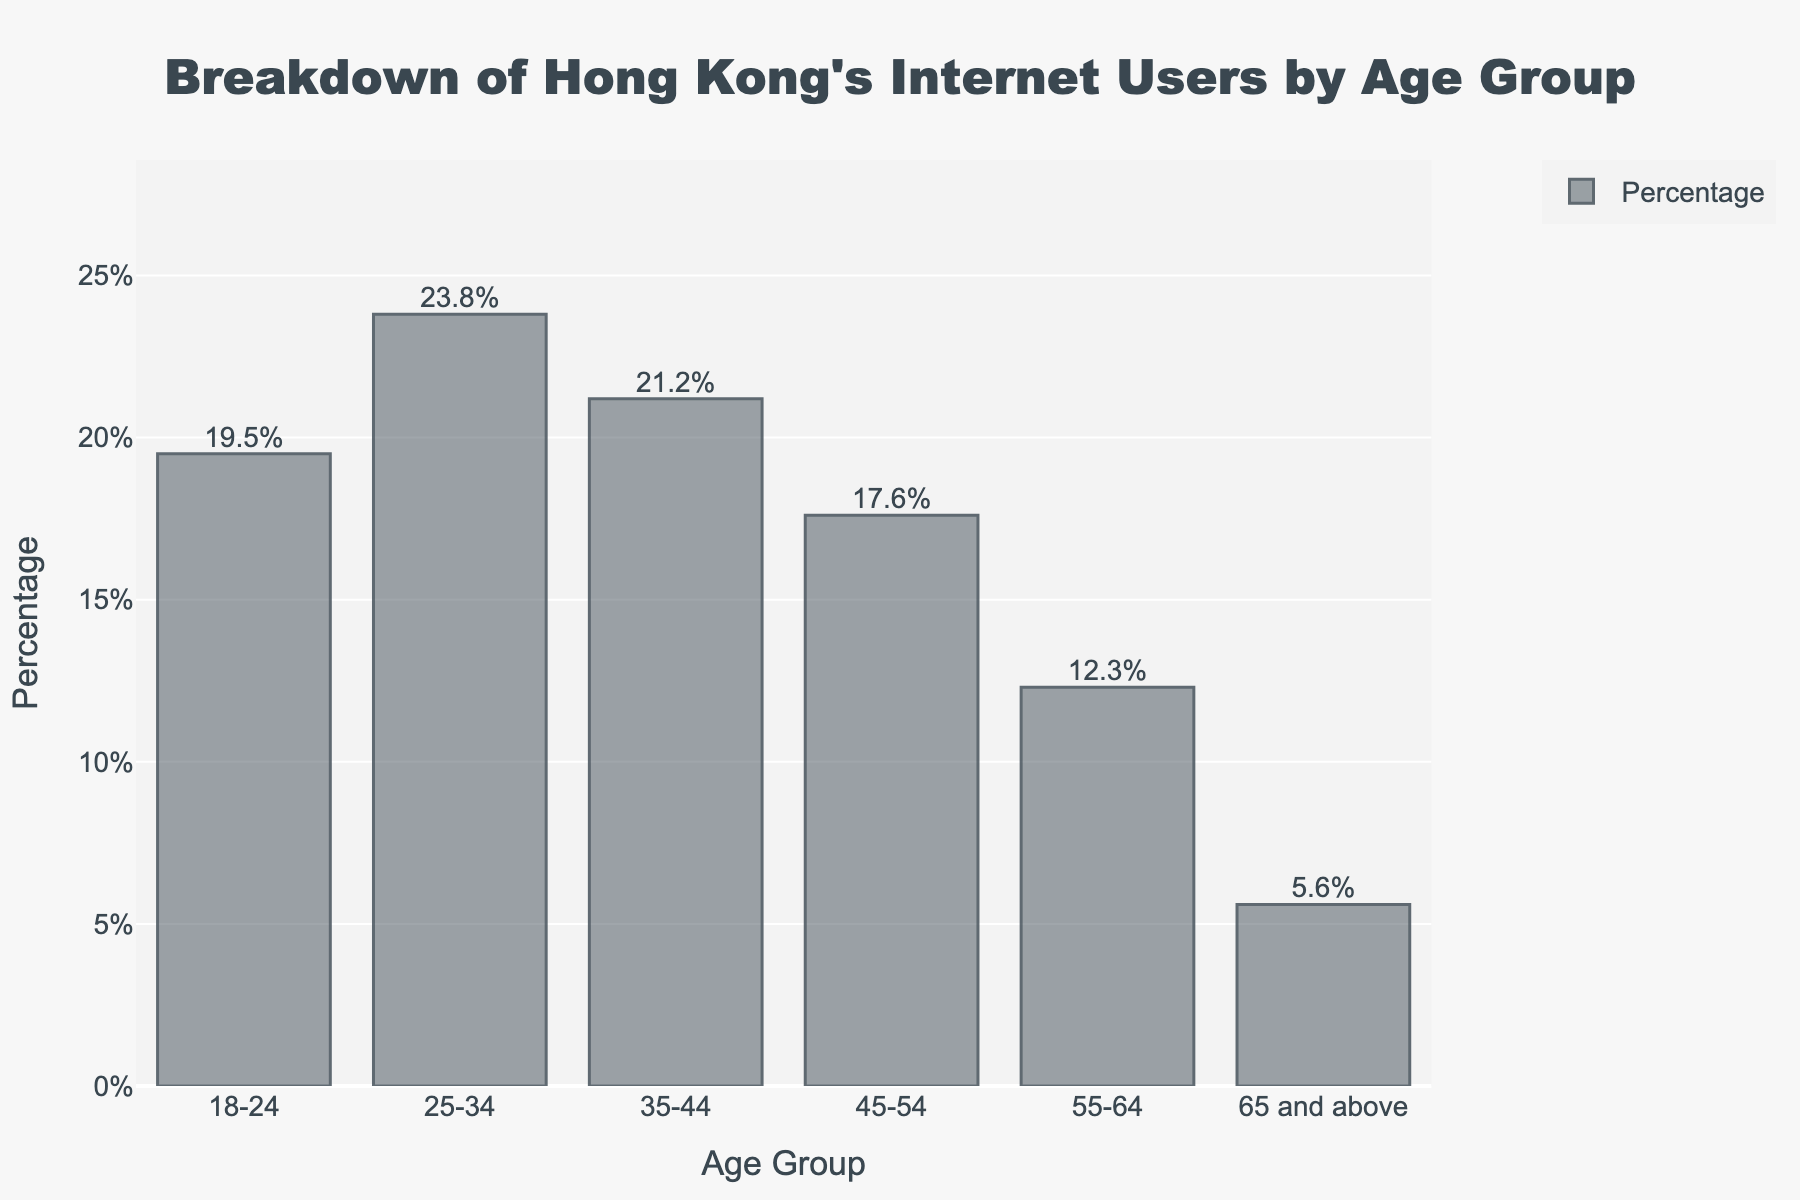Which age group has the highest percentage of internet users in Hong Kong? Looking at the bar chart, the bar with the highest height represents the highest percentage. The age group 25-34 has the highest bar
Answer: 25-34 Which age group has the lowest percentage of internet users in Hong Kong? From the bar chart, the shortest bar signifies the lowest percentage. The age group 65 and above has the shortest bar
Answer: 65 and above What is the percentage difference between the age groups 25-34 and 65 and above? The percentage for age group 25-34 is 23.8%, and for 65 and above it is 5.6%. The difference is calculated as 23.8% - 5.6%
Answer: 18.2% Which age group has a higher percentage of internet users, 18-24 or 45-54? Comparing the heights of the bars for the age groups 18-24 and 45-54, the bar for 18-24 is higher (19.5%) than 45-54 (17.6%)
Answer: 18-24 What is the total percentage of internet users in the age groups 35-44 and 55-64 combined? Add the percentages of the age groups 35-44 and 55-64: 21.2% + 12.3%
Answer: 33.5% What is the average percentage of internet users across all age groups? Sum all percentages (19.5 + 23.8 + 21.2 + 17.6 + 12.3 + 5.6) and divide by the number of age groups (6). Average = (19.5 + 23.8 + 21.2 + 17.6 + 12.3 + 5.6) / 6
Answer: 16.67% How much more percentage of internet users is there in the age group 25-34 compared to the age group 18-24? The percentage for age group 25-34 is 23.8%, and for 18-24 it is 19.5%. The difference is calculated as 23.8% - 19.5%
Answer: 4.3% What is the combined percentage of internet users for the age groups below 45 years old? Add the percentages for the age groups 18-24, 25-34, and 35-44: 19.5 + 23.8 + 21.2
Answer: 64.5% Which two age groups have the most similar percentage of internet users? By closely observing the heights of the bars, the age groups 35-44 (21.2%) and 18-24 (19.5%) are the closest in percentage
Answer: 35-44 and 18-24 What percentage is represented by the age groups 45 and above? Add the percentages for age groups 45-54, 55-64, and 65 and above: 17.6 + 12.3 + 5.6
Answer: 35.5% 